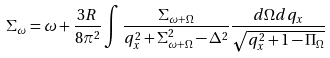Convert formula to latex. <formula><loc_0><loc_0><loc_500><loc_500>\Sigma _ { \omega } = \omega + \frac { 3 R } { 8 \pi ^ { 2 } } \int \frac { \Sigma _ { \omega + \Omega } } { q _ { x } ^ { 2 } + \Sigma ^ { 2 } _ { \omega + \Omega } - \Delta ^ { 2 } } \frac { d \Omega d q _ { x } } { \sqrt { q _ { x } ^ { 2 } + 1 - \Pi _ { \Omega } } }</formula> 